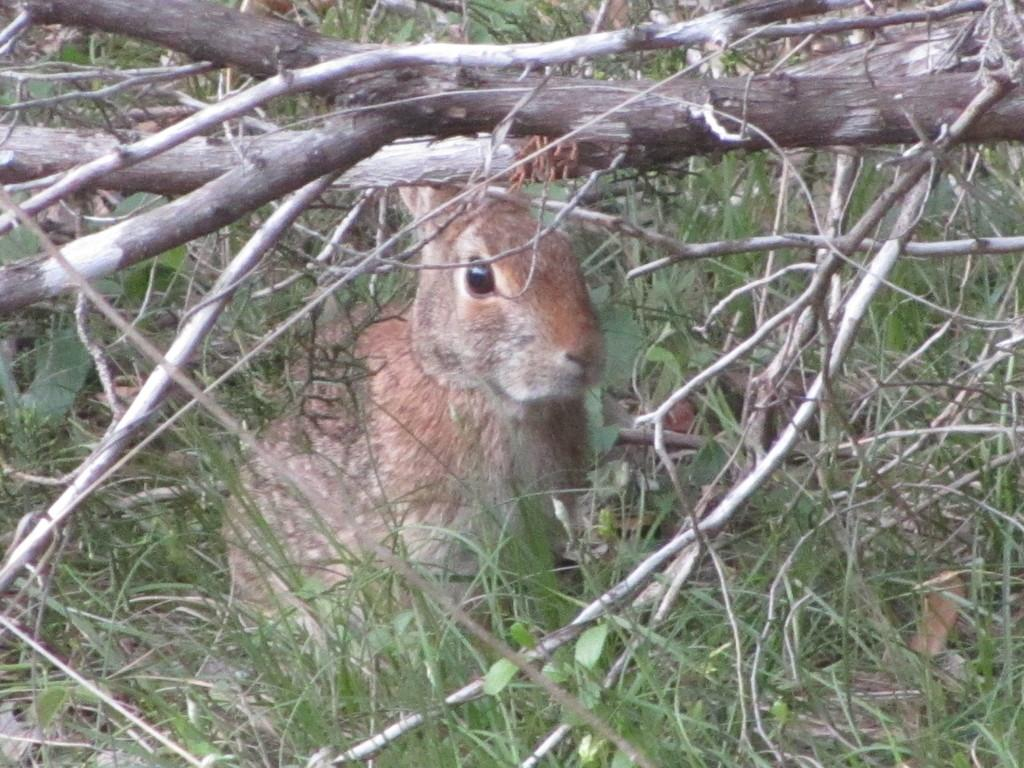What type of plant structures can be seen in the image? There are stems in the image. What type of vegetation is present in the image? There is grass in the image. What type of animal can be seen in the image? There is a rabbit visible in the image. What is the weight of the nation represented by the rabbit in the image? There is no nation represented by the rabbit in the image, and therefore no weight can be assigned to it. What type of cooking utensil is being used by the rabbit in the image? There are no cooking utensils present in the image, and the rabbit is not shown using any. 